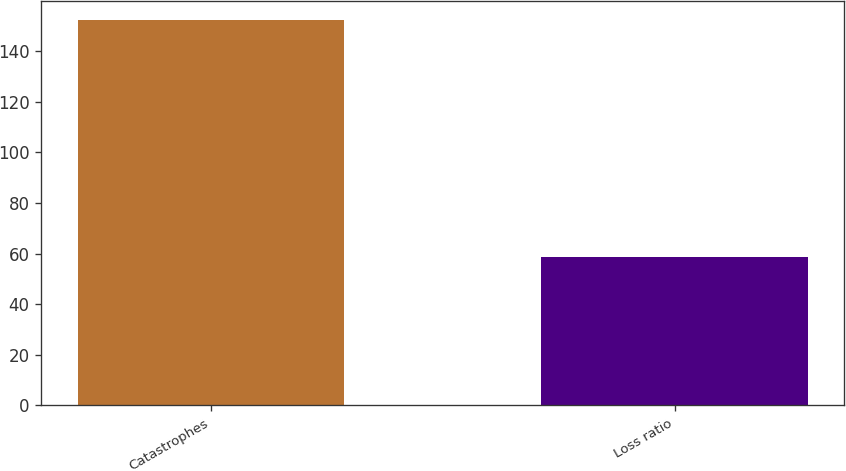Convert chart. <chart><loc_0><loc_0><loc_500><loc_500><bar_chart><fcel>Catastrophes<fcel>Loss ratio<nl><fcel>152.3<fcel>58.6<nl></chart> 